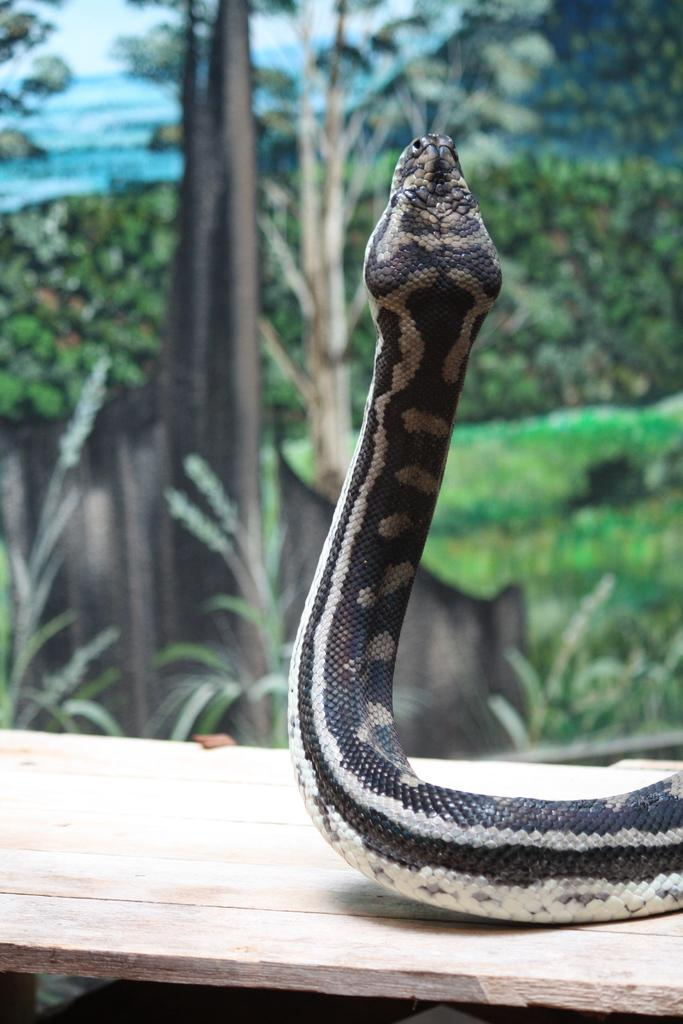What animal is present in the image? There is a snake in the image. What color is the snake? The snake is black in color. Where is the snake located? The snake is on a wooden plank. What type of mist can be seen surrounding the snake in the image? There is no mist present in the image; it only features a black snake on a wooden plank. 